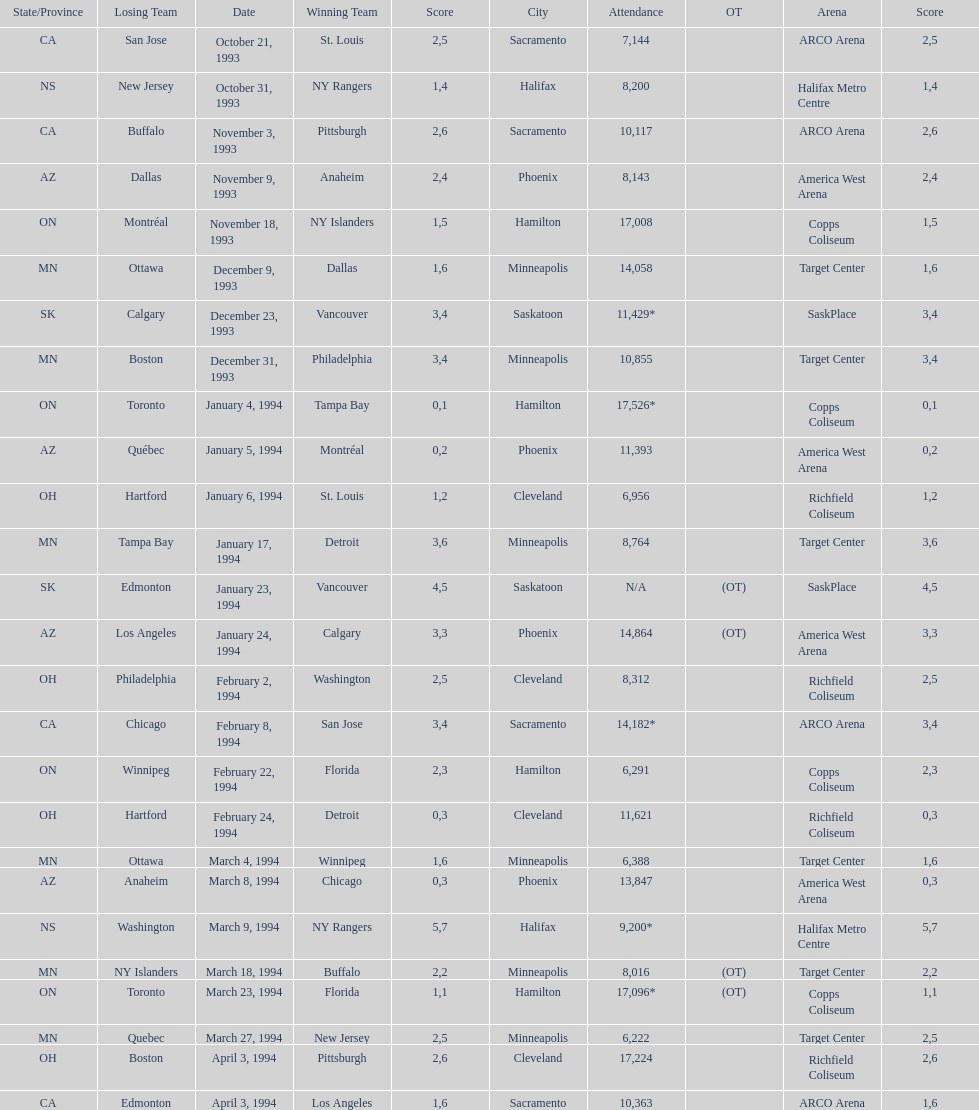I'm looking to parse the entire table for insights. Could you assist me with that? {'header': ['State/Province', 'Losing Team', 'Date', 'Winning Team', 'Score', 'City', 'Attendance', 'OT', 'Arena', 'Score'], 'rows': [['CA', 'San Jose', 'October 21, 1993', 'St. Louis', '2', 'Sacramento', '7,144', '', 'ARCO Arena', '5'], ['NS', 'New Jersey', 'October 31, 1993', 'NY Rangers', '1', 'Halifax', '8,200', '', 'Halifax Metro Centre', '4'], ['CA', 'Buffalo', 'November 3, 1993', 'Pittsburgh', '2', 'Sacramento', '10,117', '', 'ARCO Arena', '6'], ['AZ', 'Dallas', 'November 9, 1993', 'Anaheim', '2', 'Phoenix', '8,143', '', 'America West Arena', '4'], ['ON', 'Montréal', 'November 18, 1993', 'NY Islanders', '1', 'Hamilton', '17,008', '', 'Copps Coliseum', '5'], ['MN', 'Ottawa', 'December 9, 1993', 'Dallas', '1', 'Minneapolis', '14,058', '', 'Target Center', '6'], ['SK', 'Calgary', 'December 23, 1993', 'Vancouver', '3', 'Saskatoon', '11,429*', '', 'SaskPlace', '4'], ['MN', 'Boston', 'December 31, 1993', 'Philadelphia', '3', 'Minneapolis', '10,855', '', 'Target Center', '4'], ['ON', 'Toronto', 'January 4, 1994', 'Tampa Bay', '0', 'Hamilton', '17,526*', '', 'Copps Coliseum', '1'], ['AZ', 'Québec', 'January 5, 1994', 'Montréal', '0', 'Phoenix', '11,393', '', 'America West Arena', '2'], ['OH', 'Hartford', 'January 6, 1994', 'St. Louis', '1', 'Cleveland', '6,956', '', 'Richfield Coliseum', '2'], ['MN', 'Tampa Bay', 'January 17, 1994', 'Detroit', '3', 'Minneapolis', '8,764', '', 'Target Center', '6'], ['SK', 'Edmonton', 'January 23, 1994', 'Vancouver', '4', 'Saskatoon', 'N/A', '(OT)', 'SaskPlace', '5'], ['AZ', 'Los Angeles', 'January 24, 1994', 'Calgary', '3', 'Phoenix', '14,864', '(OT)', 'America West Arena', '3'], ['OH', 'Philadelphia', 'February 2, 1994', 'Washington', '2', 'Cleveland', '8,312', '', 'Richfield Coliseum', '5'], ['CA', 'Chicago', 'February 8, 1994', 'San Jose', '3', 'Sacramento', '14,182*', '', 'ARCO Arena', '4'], ['ON', 'Winnipeg', 'February 22, 1994', 'Florida', '2', 'Hamilton', '6,291', '', 'Copps Coliseum', '3'], ['OH', 'Hartford', 'February 24, 1994', 'Detroit', '0', 'Cleveland', '11,621', '', 'Richfield Coliseum', '3'], ['MN', 'Ottawa', 'March 4, 1994', 'Winnipeg', '1', 'Minneapolis', '6,388', '', 'Target Center', '6'], ['AZ', 'Anaheim', 'March 8, 1994', 'Chicago', '0', 'Phoenix', '13,847', '', 'America West Arena', '3'], ['NS', 'Washington', 'March 9, 1994', 'NY Rangers', '5', 'Halifax', '9,200*', '', 'Halifax Metro Centre', '7'], ['MN', 'NY Islanders', 'March 18, 1994', 'Buffalo', '2', 'Minneapolis', '8,016', '(OT)', 'Target Center', '2'], ['ON', 'Toronto', 'March 23, 1994', 'Florida', '1', 'Hamilton', '17,096*', '(OT)', 'Copps Coliseum', '1'], ['MN', 'Quebec', 'March 27, 1994', 'New Jersey', '2', 'Minneapolis', '6,222', '', 'Target Center', '5'], ['OH', 'Boston', 'April 3, 1994', 'Pittsburgh', '2', 'Cleveland', '17,224', '', 'Richfield Coliseum', '6'], ['CA', 'Edmonton', 'April 3, 1994', 'Los Angeles', '1', 'Sacramento', '10,363', '', 'ARCO Arena', '6']]} Who won the game the day before the january 5, 1994 game? Tampa Bay. 